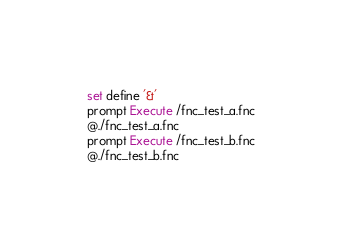Convert code to text. <code><loc_0><loc_0><loc_500><loc_500><_SQL_>set define '&'
prompt Execute /fnc_test_a.fnc
@./fnc_test_a.fnc
prompt Execute /fnc_test_b.fnc
@./fnc_test_b.fnc</code> 